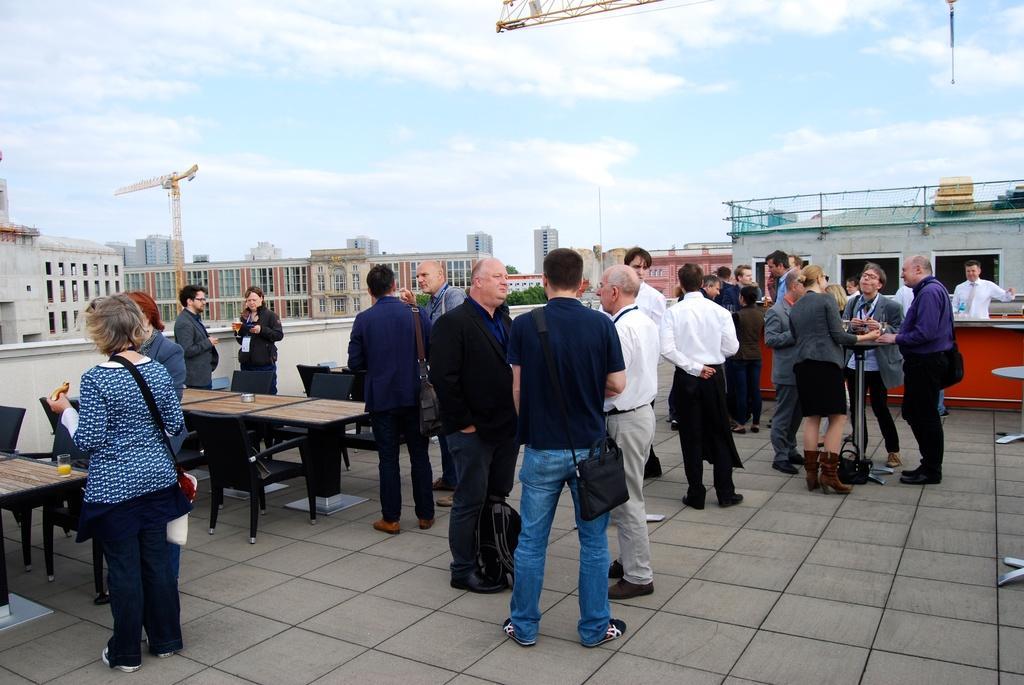How would you summarize this image in a sentence or two? This image is clicked on the terrors. There are many people in this image. To the left, the woman standing is wearing blue dress. At the bottom, there is a floor. At the top, there is a crane. In the background, there are buildings. There are many tables and chairs in this image. 